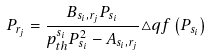<formula> <loc_0><loc_0><loc_500><loc_500>P _ { r _ { j } } = \frac { B _ { s _ { i } , r _ { j } } P _ { s _ { i } } } { p _ { t h } ^ { s _ { i } } P _ { s _ { i } } ^ { 2 } - A _ { s _ { i } , r _ { j } } } \triangle q f \left ( P _ { s _ { i } } \right )</formula> 